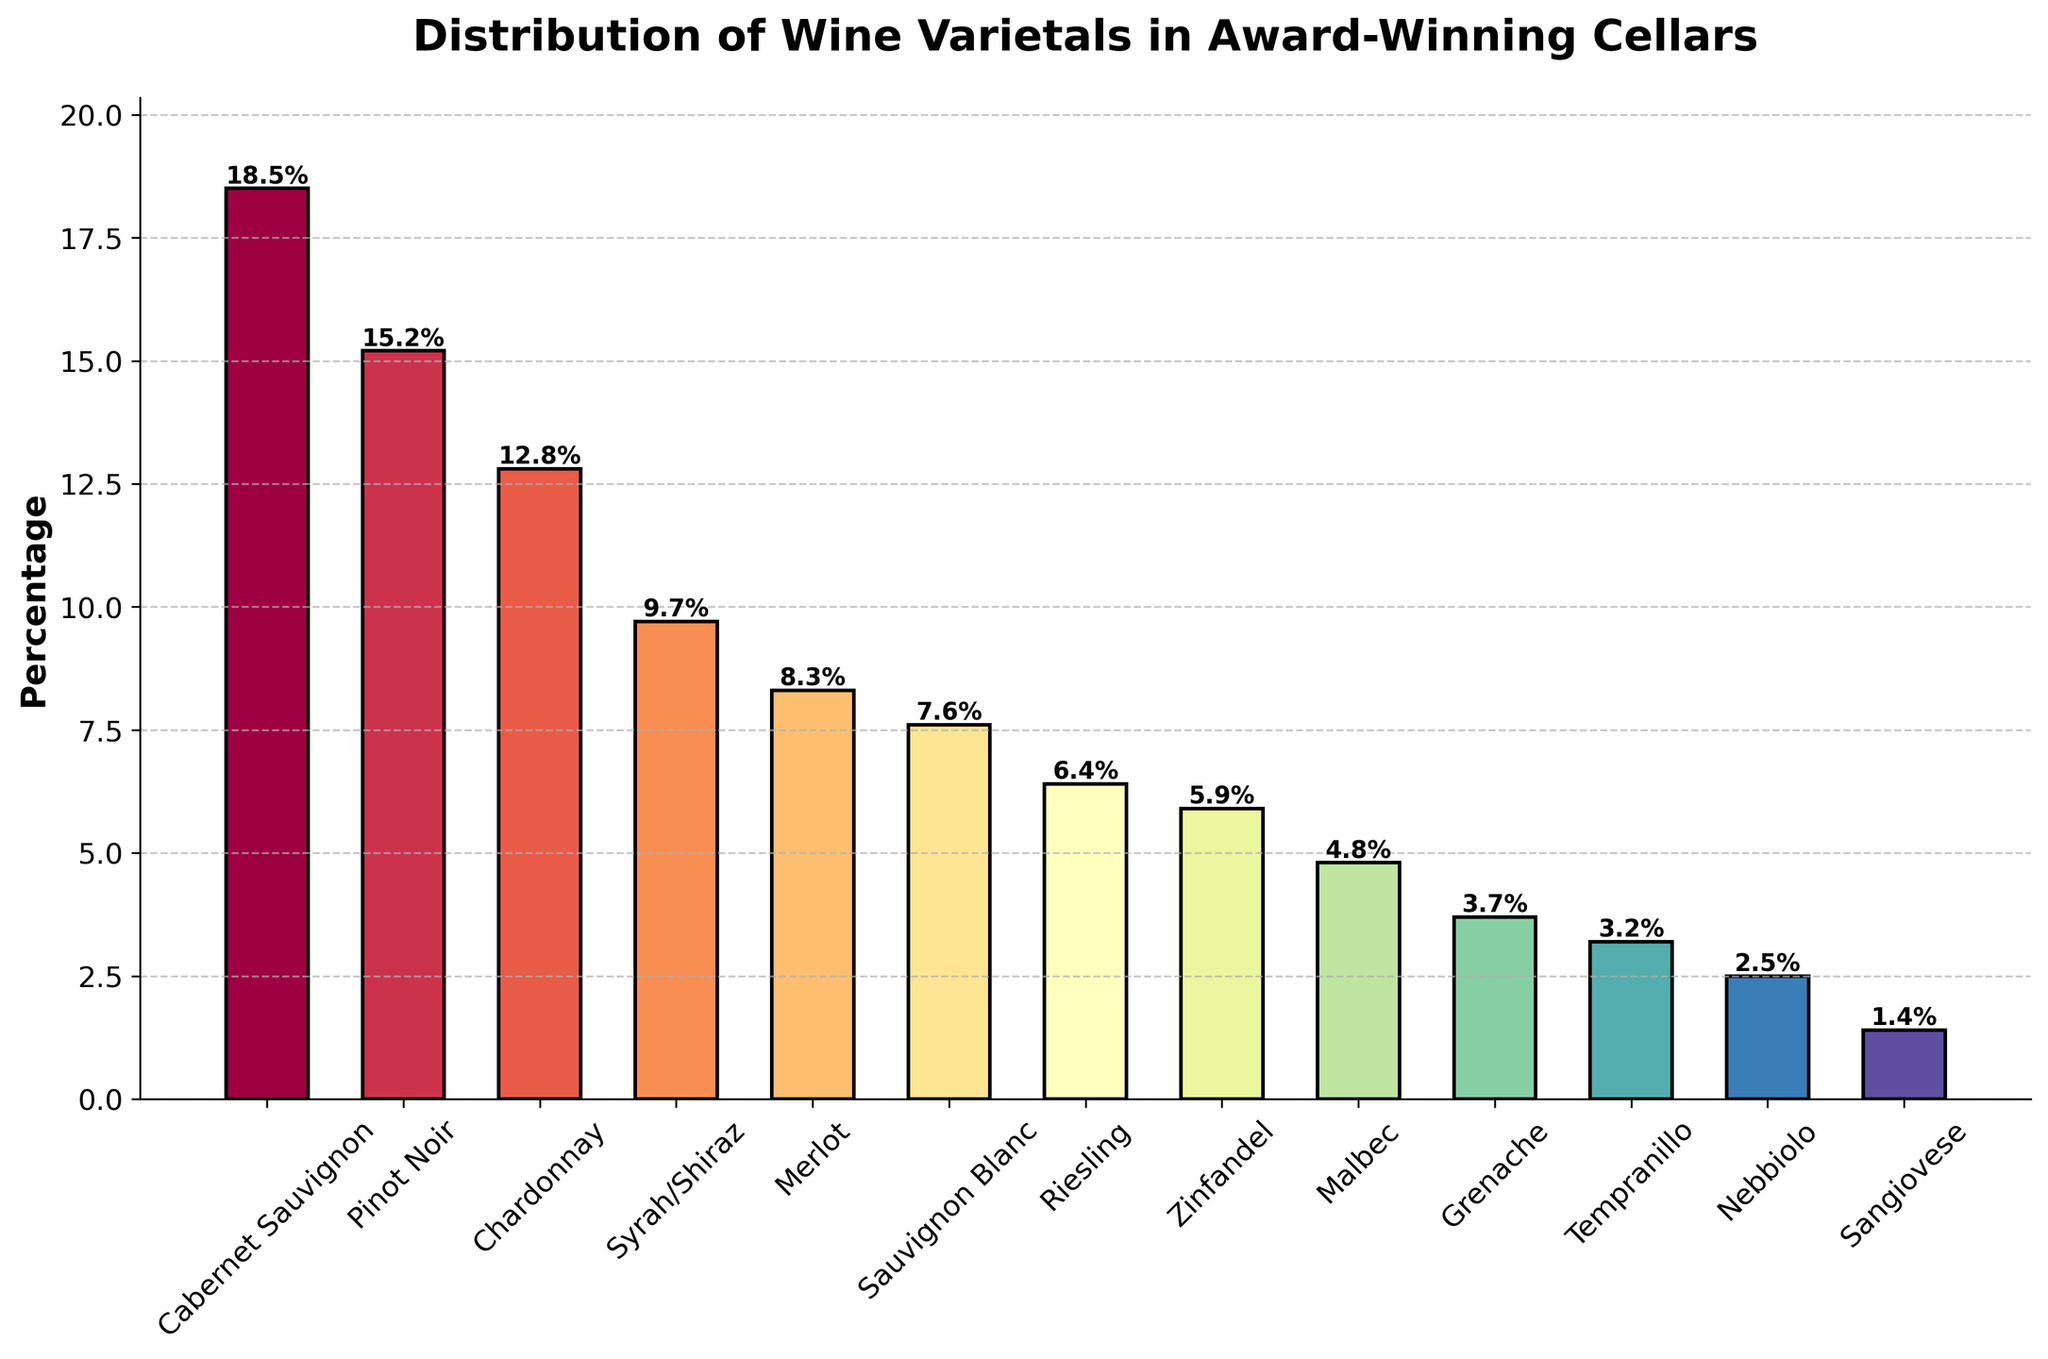Which wine varietal holds the largest percentage in award-winning cellars? Identify the tallest bar in the bar chart, which represents the varietal with the highest percentage.
Answer: Cabernet Sauvignon What is the combined percentage of Pinot Noir and Chardonnay? Locate the bars for Pinot Noir and Chardonnay, read their percentages (15.2 and 12.8 respectively), and sum those values: 15.2 + 12.8 = 28.0
Answer: 28.0% Which varietal has a higher percentage, Syrah/Shiraz or Merlot? Compare the heights of the bars for Syrah/Shiraz (9.7%) and Merlot (8.3%). Syrah/Shiraz has a higher percentage.
Answer: Syrah/Shiraz What is the difference in percentage between Sauvignon Blanc and Riesling? Locate the bars for Sauvignon Blanc and Riesling, read their percentages (7.6 and 6.4 respectively), and subtract the smaller value from the larger value: 7.6 - 6.4 = 1.2
Answer: 1.2% Which varietal contributes more to the total, Zinfandel or Malbec? Compare the heights of the bars for Zinfandel (5.9%) and Malbec (4.8%). Zinfandel has a higher percentage.
Answer: Zinfandel What is the average percentage of Tempranillo, Nebbiolo, and Sangiovese? Locate the bars for Tempranillo, Nebbiolo, and Sangiovese, read their percentages (3.2, 2.5, and 1.4 respectively), sum those values and divide by 3: (3.2 + 2.5 + 1.4) / 3 ≈ 2.37
Answer: 2.37% Which varietals have a percentage greater than 10%? Identify the bars that have a height corresponding to a percentage greater than 10. These are Cabernet Sauvignon (18.5%), Pinot Noir (15.2%), and Chardonnay (12.8%).
Answer: Cabernet Sauvignon, Pinot Noir, Chardonnay What is the total percentage of Cabernet Sauvignon, Pinot Noir, Chardonnay, and Syrah/Shiraz combined? Locate the bars for each of these varietals and sum their percentages: 18.5 + 15.2 + 12.8 + 9.7 = 56.2
Answer: 56.2% Which varietals have percentages less than 5%? Identify the bars that have a height corresponding to a percentage less than 5. These are Malbec (4.8%), Grenache (3.7%), Tempranillo (3.2%), Nebbiolo (2.5%), and Sangiovese (1.4%).
Answer: Malbec, Grenache, Tempranillo, Nebbiolo, Sangiovese How much more percentage does Cabernet Sauvignon have compared to Grenache? Locate the bars for Cabernet Sauvignon and Grenache, read their percentages (18.5 and 3.7 respectively), and subtract the smaller value from the larger value: 18.5 - 3.7 = 14.8
Answer: 14.8% 